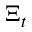<formula> <loc_0><loc_0><loc_500><loc_500>\Xi _ { t }</formula> 